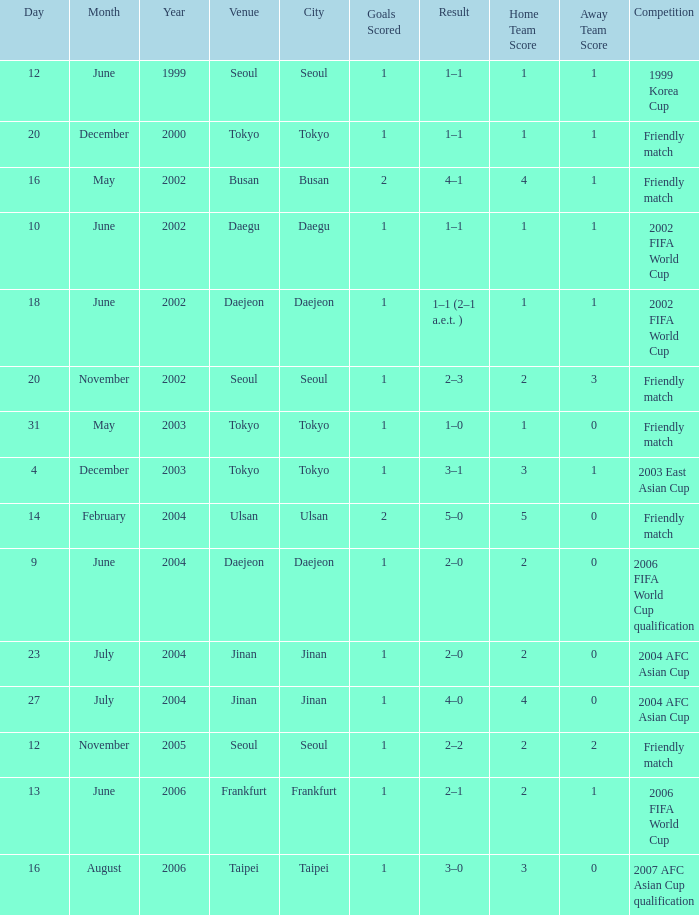Help me parse the entirety of this table. {'header': ['Day', 'Month', 'Year', 'Venue', 'City', 'Goals Scored', 'Result', 'Home Team Score', 'Away Team Score', 'Competition'], 'rows': [['12', 'June', '1999', 'Seoul', 'Seoul', '1', '1–1', '1', '1', '1999 Korea Cup'], ['20', 'December', '2000', 'Tokyo', 'Tokyo', '1', '1–1', '1', '1', 'Friendly match'], ['16', 'May', '2002', 'Busan', 'Busan', '2', '4–1', '4', '1', 'Friendly match'], ['10', 'June', '2002', 'Daegu', 'Daegu', '1', '1–1', '1', '1', '2002 FIFA World Cup'], ['18', 'June', '2002', 'Daejeon', 'Daejeon', '1', '1–1 (2–1 a.e.t. )', '1', '1', '2002 FIFA World Cup'], ['20', 'November', '2002', 'Seoul', 'Seoul', '1', '2–3', '2', '3', 'Friendly match'], ['31', 'May', '2003', 'Tokyo', 'Tokyo', '1', '1–0', '1', '0', 'Friendly match'], ['4', 'December', '2003', 'Tokyo', 'Tokyo', '1', '3–1', '3', '1', '2003 East Asian Cup'], ['14', 'February', '2004', 'Ulsan', 'Ulsan', '2', '5–0', '5', '0', 'Friendly match'], ['9', 'June', '2004', 'Daejeon', 'Daejeon', '1', '2–0', '2', '0', '2006 FIFA World Cup qualification'], ['23', 'July', '2004', 'Jinan', 'Jinan', '1', '2–0', '2', '0', '2004 AFC Asian Cup'], ['27', 'July', '2004', 'Jinan', 'Jinan', '1', '4–0', '4', '0', '2004 AFC Asian Cup'], ['12', 'November', '2005', 'Seoul', 'Seoul', '1', '2–2', '2', '2', 'Friendly match'], ['13', 'June', '2006', 'Frankfurt', 'Frankfurt', '1', '2–1', '2', '1', '2006 FIFA World Cup'], ['16', 'August', '2006', 'Taipei', 'Taipei', '1', '3–0', '3', '0', '2007 AFC Asian Cup qualification']]} What is the venue of the game on 20 November 2002? Seoul. 